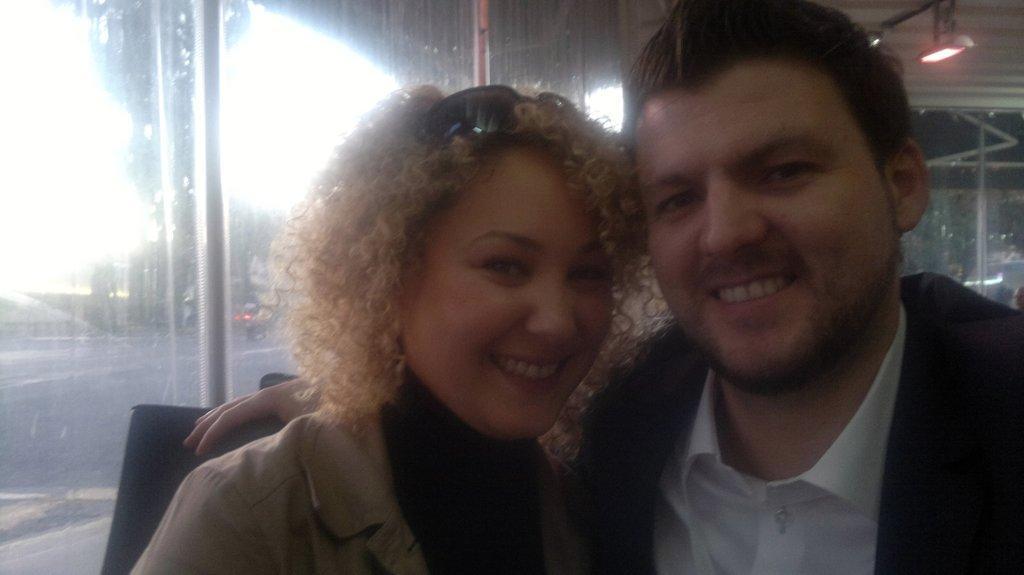Can you describe this image briefly? In this image we can see two persons, behind them there are lights, windows. 